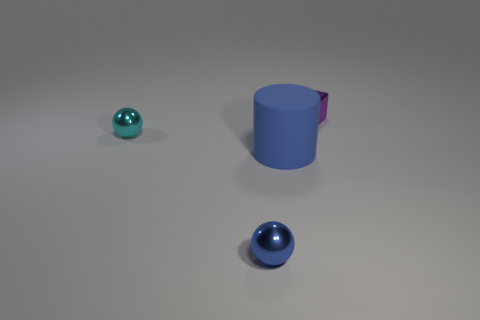Subtract all purple cylinders. Subtract all brown balls. How many cylinders are left? 1 Subtract all cyan spheres. How many gray cylinders are left? 0 Add 1 objects. How many blues exist? 0 Subtract all tiny purple blocks. Subtract all big matte things. How many objects are left? 2 Add 1 big blue rubber cylinders. How many big blue rubber cylinders are left? 2 Add 3 cyan balls. How many cyan balls exist? 4 Add 1 tiny cyan objects. How many objects exist? 5 Subtract all cyan spheres. How many spheres are left? 1 Subtract 0 brown cubes. How many objects are left? 4 Subtract all cubes. How many objects are left? 3 